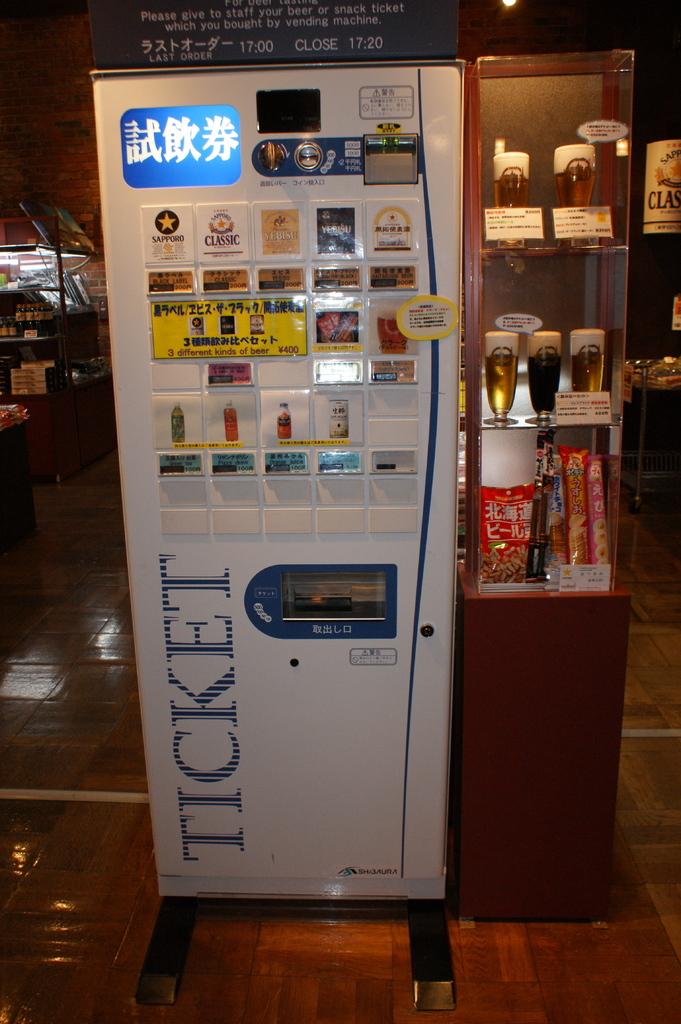What can you get in this machine?
Make the answer very short. Ticket. 